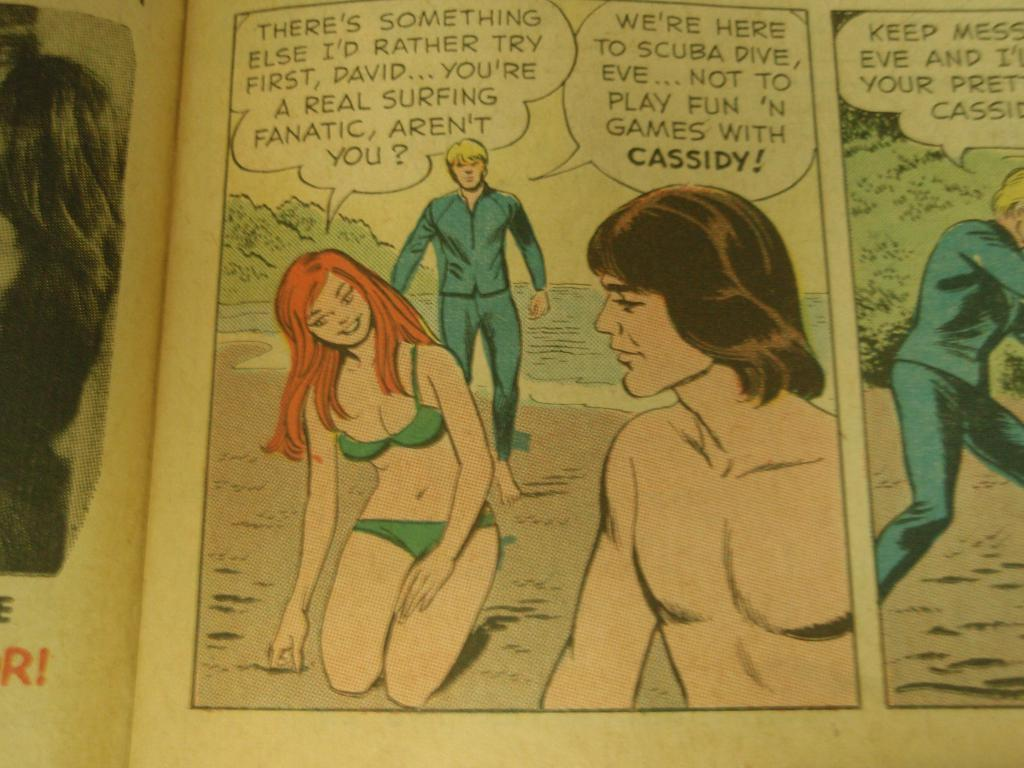<image>
Offer a succinct explanation of the picture presented. Comic book about men and a girl that are surfing 